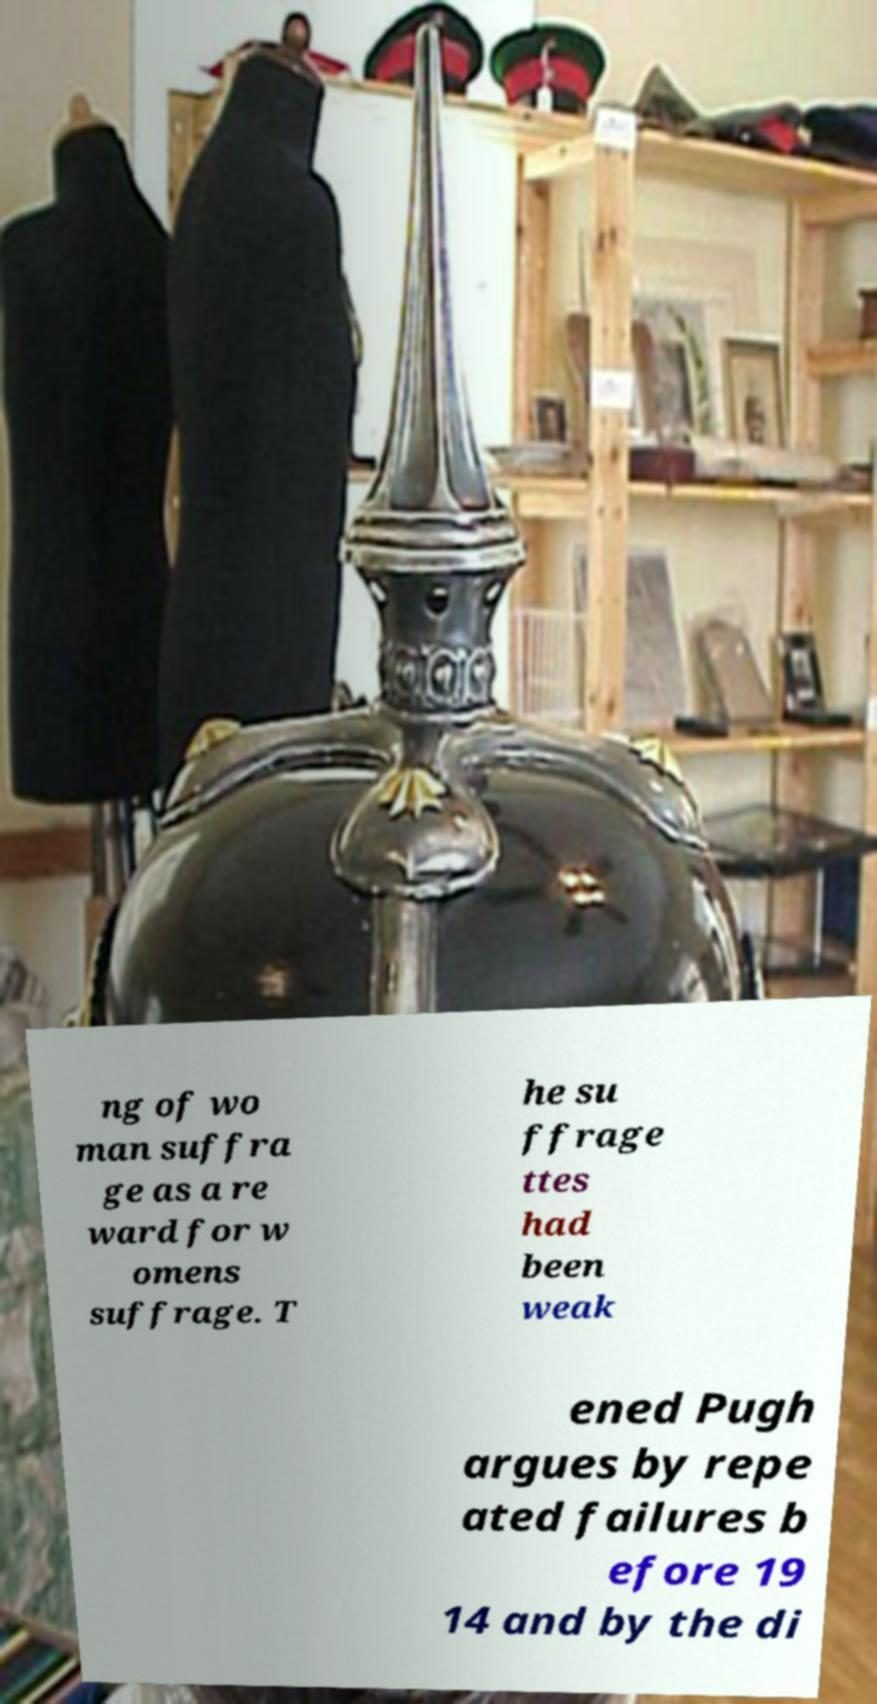Can you read and provide the text displayed in the image?This photo seems to have some interesting text. Can you extract and type it out for me? ng of wo man suffra ge as a re ward for w omens suffrage. T he su ffrage ttes had been weak ened Pugh argues by repe ated failures b efore 19 14 and by the di 